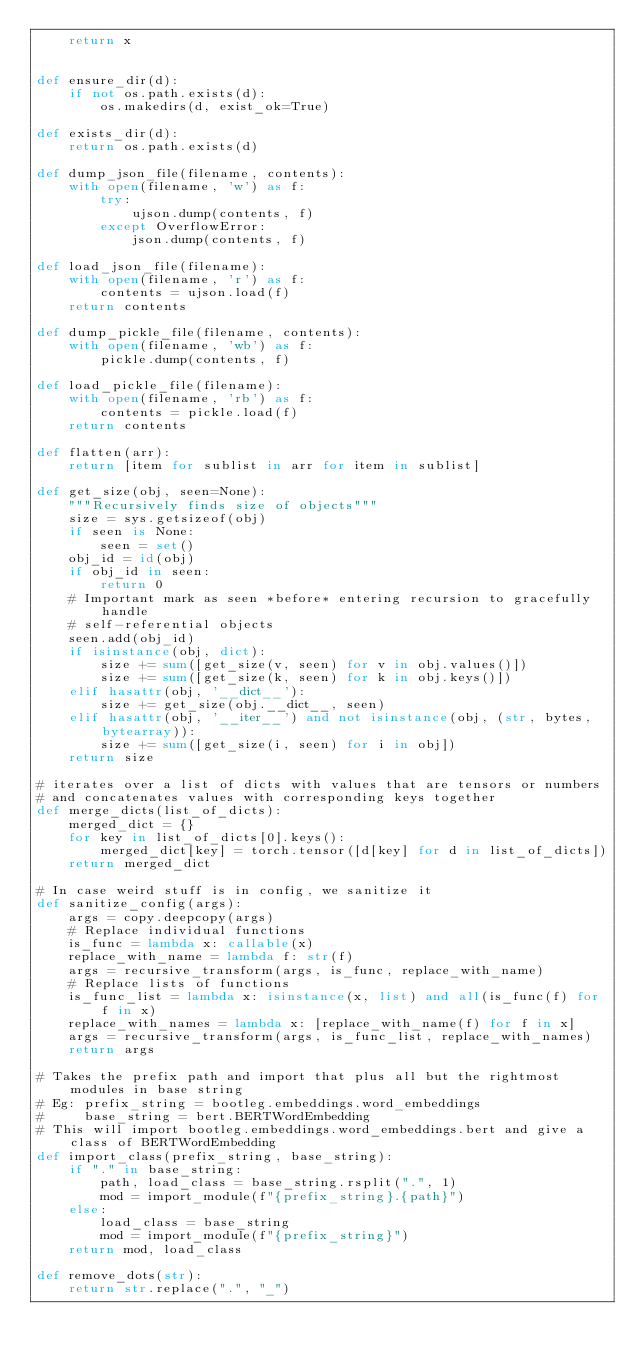<code> <loc_0><loc_0><loc_500><loc_500><_Python_>    return x


def ensure_dir(d):
    if not os.path.exists(d):
        os.makedirs(d, exist_ok=True)

def exists_dir(d):
    return os.path.exists(d)

def dump_json_file(filename, contents):
    with open(filename, 'w') as f:
        try:
            ujson.dump(contents, f)
        except OverflowError:
            json.dump(contents, f)

def load_json_file(filename):
    with open(filename, 'r') as f:
        contents = ujson.load(f)
    return contents

def dump_pickle_file(filename, contents):
    with open(filename, 'wb') as f:
        pickle.dump(contents, f)

def load_pickle_file(filename):
    with open(filename, 'rb') as f:
        contents = pickle.load(f)
    return contents

def flatten(arr):
    return [item for sublist in arr for item in sublist]

def get_size(obj, seen=None):
    """Recursively finds size of objects"""
    size = sys.getsizeof(obj)
    if seen is None:
        seen = set()
    obj_id = id(obj)
    if obj_id in seen:
        return 0
    # Important mark as seen *before* entering recursion to gracefully handle
    # self-referential objects
    seen.add(obj_id)
    if isinstance(obj, dict):
        size += sum([get_size(v, seen) for v in obj.values()])
        size += sum([get_size(k, seen) for k in obj.keys()])
    elif hasattr(obj, '__dict__'):
        size += get_size(obj.__dict__, seen)
    elif hasattr(obj, '__iter__') and not isinstance(obj, (str, bytes, bytearray)):
        size += sum([get_size(i, seen) for i in obj])
    return size

# iterates over a list of dicts with values that are tensors or numbers
# and concatenates values with corresponding keys together
def merge_dicts(list_of_dicts):
    merged_dict = {}
    for key in list_of_dicts[0].keys():
        merged_dict[key] = torch.tensor([d[key] for d in list_of_dicts])
    return merged_dict

# In case weird stuff is in config, we sanitize it
def sanitize_config(args):
    args = copy.deepcopy(args)
    # Replace individual functions
    is_func = lambda x: callable(x)
    replace_with_name = lambda f: str(f)
    args = recursive_transform(args, is_func, replace_with_name)
    # Replace lists of functions
    is_func_list = lambda x: isinstance(x, list) and all(is_func(f) for f in x)
    replace_with_names = lambda x: [replace_with_name(f) for f in x]
    args = recursive_transform(args, is_func_list, replace_with_names)
    return args

# Takes the prefix path and import that plus all but the rightmost modules in base string
# Eg: prefix_string = bootleg.embeddings.word_embeddings
#     base_string = bert.BERTWordEmbedding
# This will import bootleg.embeddings.word_embeddings.bert and give a class of BERTWordEmbedding
def import_class(prefix_string, base_string):
    if "." in base_string:
        path, load_class = base_string.rsplit(".", 1)
        mod = import_module(f"{prefix_string}.{path}")
    else:
        load_class = base_string
        mod = import_module(f"{prefix_string}")
    return mod, load_class

def remove_dots(str):
    return str.replace(".", "_")</code> 